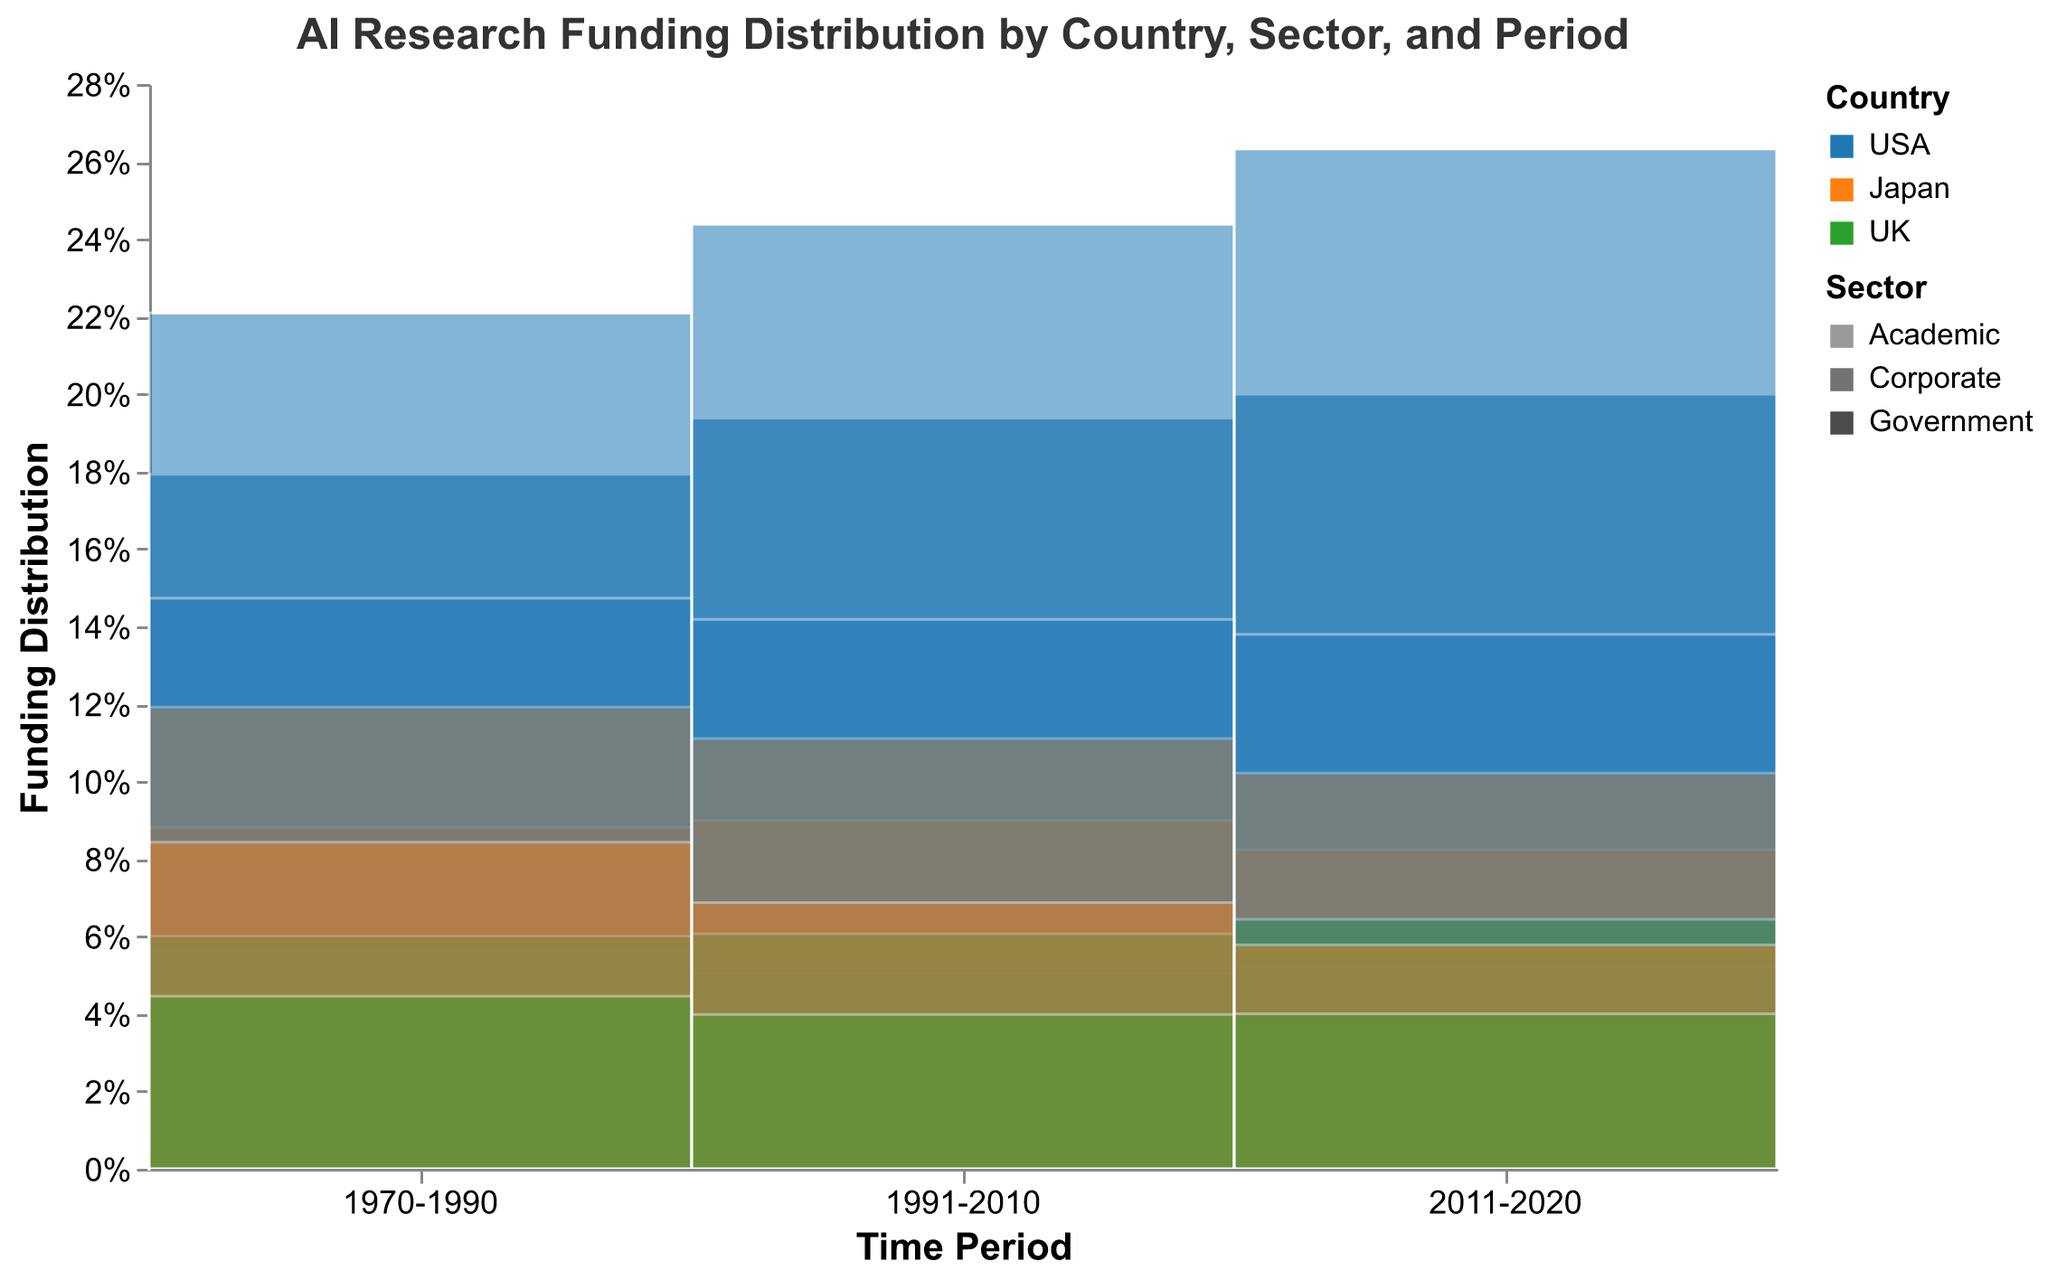What is the total funding in the USA for the period 2011-2020? According to the figure, the USA's funds for the period 2011-2020 are from three sectors: Academic (98.3), Corporate (187.6), and Government (142.5) billion USD. Summing these amounts gives a total: 98.3 + 187.6 + 142.5.
Answer: 428.4 billion USD Which country had the highest corporate funding in 1991-2010? To find the country with the highest corporate funding in 1991-2010, compare corporate funding values for USA (78.4), Japan (35.7), and UK (19.5) for this period. The USA has the highest funding of 78.4 billion USD.
Answer: USA How has the funding distribution in the academic sector changed from 1970-1990 to 2011-2020 for Japan? Compare Japan's academic sector funding in 1970-1990 (8.7 billion USD) to 2011-2020 (41.2 billion USD). There is a significant increase.
Answer: Increased What percentage of total funding in the UK was contributed by the government sector in 1991-2010? Using the figure, add the UK’s funding for Academic (12.8), Corporate (19.5), and Government (16.2) sectors in 1991-2010. The total = 12.8 + 19.5 + 16.2 = 48.5 billion USD. Then calculate the percentage from government funding: (16.2 / 48.5) * 100.
Answer: 33.4% How does the total AI research funding compare between Japan and the UK for the period 1970-1990? Add Japan’s total funding for 1970-1990 (Academic: 8.7, Corporate: 12.3, Government: 9.1) which equals 30.1 billion USD. For the UK: (Academic: 4.6, Corporate: 6.2, Government: 5.8) equals 16.6 billion USD. Comparing these totals, Japan’s funding (30.1) is significantly higher than the UK’s (16.6).
Answer: Japan has higher funding What is the trend in government funding for AI research in the USA from 1970-2020? Observe the USA’s government funding over the time periods: 18.5 billion USD (1970-1990), 62.3 billion USD (1991-2010), and 142.5 billion USD (2011-2020). The trend shows consistent and dramatic increases.
Answer: Increasing Which sector received the least funding in the UK in the 2011-2020 period? Look at the sectors in the UK during 2011-2020: Academic (28.5), Corporate (45.9), and Government (37.1) billion USD. The academic sector received the least funding.
Answer: Academic By how much did the total funding for AI research in the USA increase from 1991-2010 to 2011-2020? Calculate the total funding for the USA in 1991-2010 (Academic: 45.6, Corporate: 78.4, Government: 62.3) which equals 186.3 billion USD. In 2011-2020, it is (Academic: 98.3, Corporate: 187.6, Government: 142.5) which equals 428.4 billion USD. The increase is 428.4 - 186.3.
Answer: 242.1 billion USD What can be said about the distribution of funding among the sectors in Japan in the period 1970-1990? View Japan's funding in 1970-1990: Academic (8.7), Corporate (12.3), Government (9.1). Corporate has the highest, followed by Government, and Academic is the lowest. The funding is fairly spread with Corporate slightly dominant.
Answer: Corporate sector leads How does the relative funding for AI research change over the periods for the Academic sector in the USA? Investigate USA's Academic funding across periods: 15.2 (1970-1990), 45.6 (1991-2010), 98.3 (2011-2020). Each period shows a substantial increase in funding.
Answer: Substantially increasing 